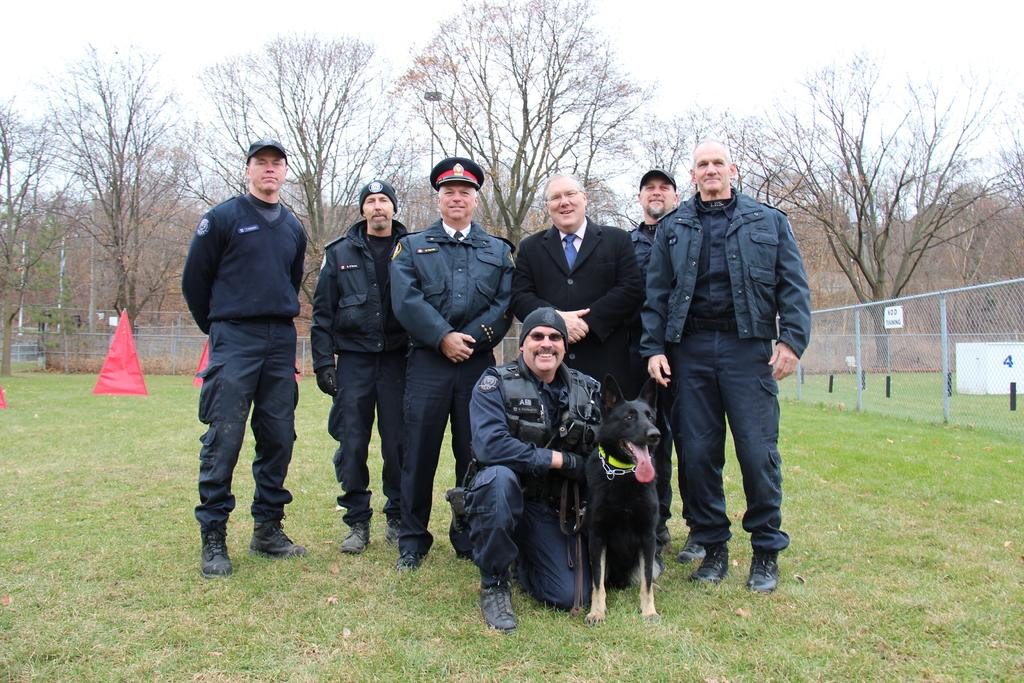What is happening in the image involving the group of people? There is a group of people standing on the ground in the image. What animal is present in the image? There is a dog in the image. What can be seen in the background of the image? There are trees visible in the background. What part of the natural environment is visible in the image? The sky is visible in the image. What type of soup is being served in the image? There is no soup present in the image. How many crows are sitting on the dog's head in the image? There are no crows present in the image, and the dog's head is not mentioned. 